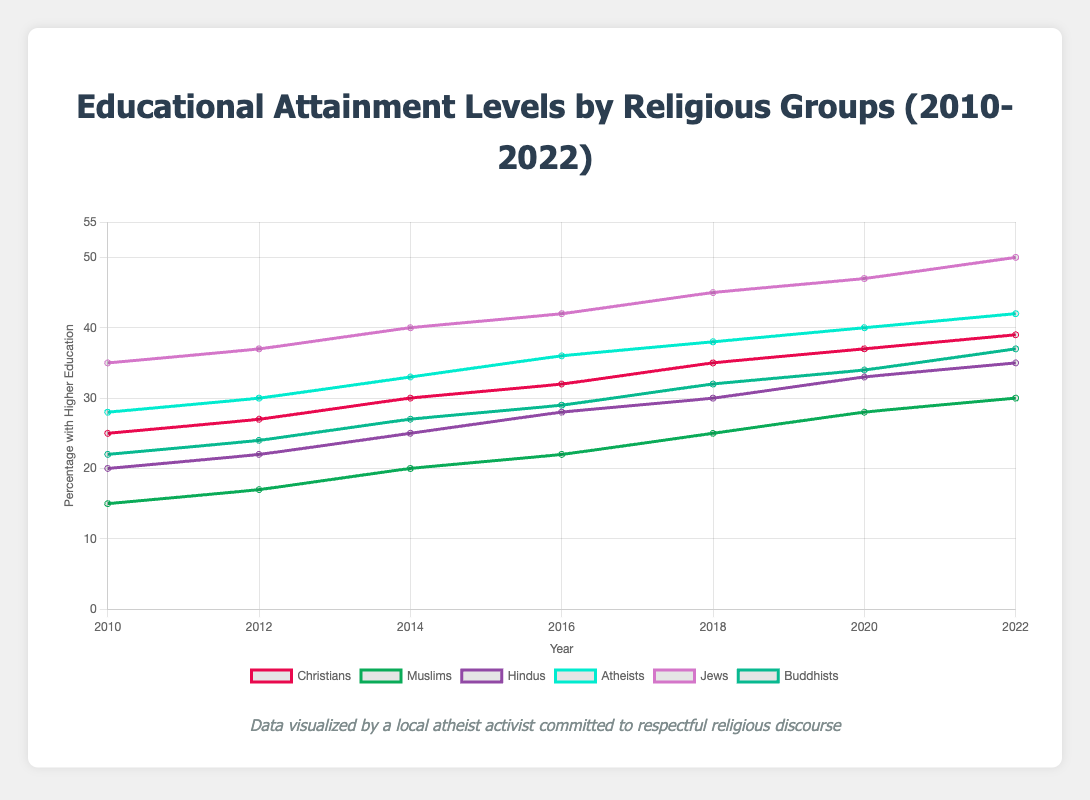What was the percentage of Christians with higher education in 2016? Look at the line corresponding to Christians and locate the point for the year 2016. You will find the percentage is 32.
Answer: 32 Which group showed the highest percentage of higher education in 2022? Identify the highest percentage on the chart for the year 2022. Jews reached 50%, which is higher than any other group.
Answer: Jews Between 2014 and 2016, did Muslims show an increase or a decrease in the percentage of higher education? Find the percentages for Muslims in 2014 and 2016, which are 20% and 22%, respectively. Since 22% is greater than 20%, there was an increase.
Answer: Increase Calculate the average percentage of higher education for Hindus over the entire time period. Sum the percentages for all years for Hindus (20 + 22 + 25 + 28 + 30 + 33 + 35 = 193) and divide by the number of years (7). 193/7 ≈ 27.57.
Answer: 27.57 Did any group have a higher percentage of higher education than Atheists in 2020? Compare the percentage for Atheists in 2020 (40%) with other groups. Only Jews in 2020 at 47% had a higher percentage.
Answer: Yes, Jews Which group experienced the largest percentage increase from 2010 to 2022? Calculate the difference for each group: 
Christians: 39 - 25 = 14
Muslims: 30 - 15 = 15
Hindus: 35 - 20 = 15
Atheists: 42 - 28 = 14
Jews: 50 - 35 = 15
Buddhists: 37 - 22 = 15
Compare the results; Muslims, Hindus, Jews, and Buddhists have the largest increase of 15%.
Answer: Muslims, Hindus, Jews, Buddhists What is the difference between the percentages of higher education for Buddhists and Atheists in 2018? Subtract the percentage for Buddhists (32%) from Atheists (38%) in 2018. 38 - 32 = 6.
Answer: 6 Which group had the lowest percentage of higher education in 2012? Find the lowest percentage in 2012 across all groups. Muslims had the lowest percentage at 17%.
Answer: Muslims Compare the increase in higher education levels for Christians and Buddhists from 2010 to 2016. Calculate the differences for both groups between 2010 and 2016:
Christians: 32 - 25 = 7
Buddhists: 29 - 22 = 7
Both groups experienced an increase of 7%.
Answer: Equal Is the trend of higher education levels for all groups increasing over the years observed in the data? Examine the lines for all groups from 2010 to 2022. All lines show an upward trend, indicating increasing educational levels.
Answer: Yes 